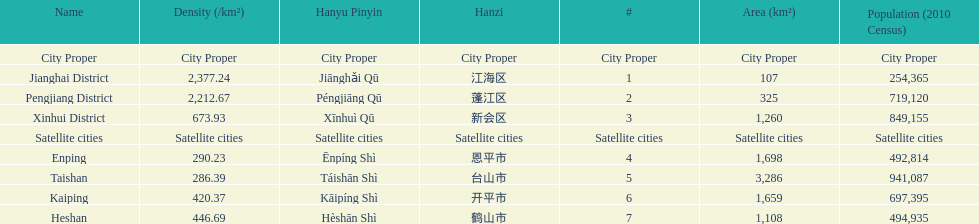What is the difference in population between enping and heshan? 2121. 